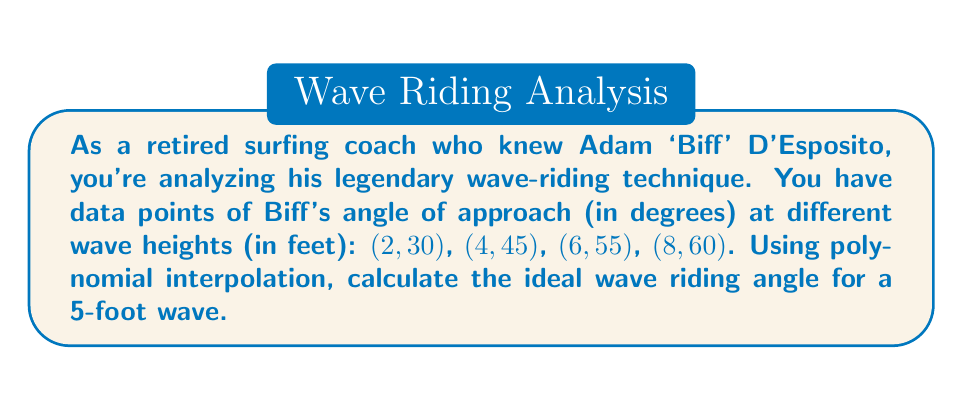Teach me how to tackle this problem. To solve this problem, we'll use Lagrange polynomial interpolation:

1) The Lagrange interpolation polynomial is given by:
   $$P(x) = \sum_{i=1}^n y_i \cdot L_i(x)$$
   where $L_i(x) = \prod_{j \neq i} \frac{x - x_j}{x_i - x_j}$

2) We have four data points: $(x_1, y_1) = (2, 30)$, $(x_2, y_2) = (4, 45)$, $(x_3, y_3) = (6, 55)$, $(x_4, y_4) = (8, 60)$

3) Calculate each $L_i(5)$:

   $L_1(5) = \frac{(5-4)(5-6)(5-8)}{(2-4)(2-6)(2-8)} = \frac{1 \cdot (-1) \cdot (-3)}{(-2)(-4)(-6)} = -\frac{1}{8}$

   $L_2(5) = \frac{(5-2)(5-6)(5-8)}{(4-2)(4-6)(4-8)} = \frac{3 \cdot (-1) \cdot (-3)}{2(-2)(-4)} = -\frac{9}{8}$

   $L_3(5) = \frac{(5-2)(5-4)(5-8)}{(6-2)(6-4)(6-8)} = \frac{3 \cdot 1 \cdot (-3)}{4 \cdot 2 \cdot (-2)} = \frac{9}{8}$

   $L_4(5) = \frac{(5-2)(5-4)(5-6)}{(8-2)(8-4)(8-6)} = \frac{3 \cdot 1 \cdot (-1)}{6 \cdot 4 \cdot 2} = -\frac{1}{8}$

4) Now, we can calculate $P(5)$:

   $P(5) = 30 \cdot (-\frac{1}{8}) + 45 \cdot (-\frac{9}{8}) + 55 \cdot \frac{9}{8} + 60 \cdot (-\frac{1}{8})$

   $= -3.75 - 50.625 + 61.875 - 7.5 = 50$

Therefore, the ideal wave riding angle for a 5-foot wave is 50 degrees.
Answer: 50 degrees 